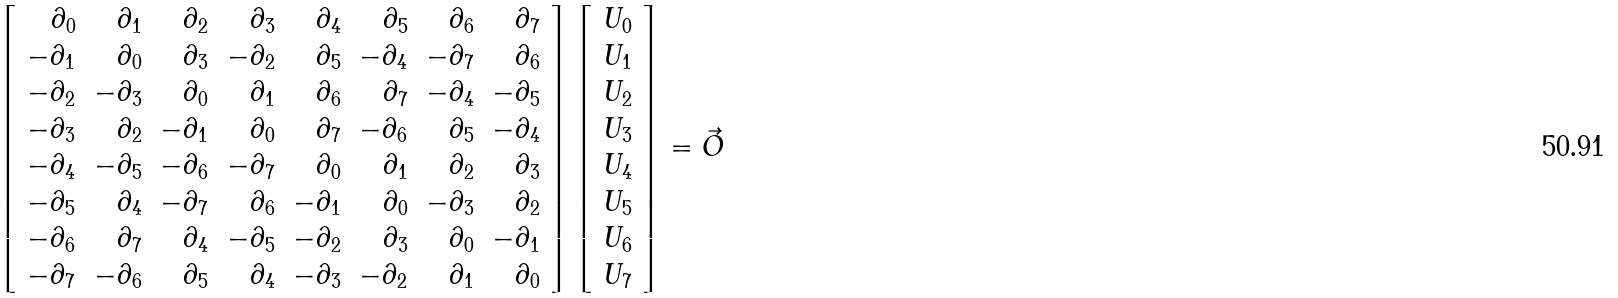Convert formula to latex. <formula><loc_0><loc_0><loc_500><loc_500>\left [ \begin{array} { r r r r r r r r } \partial _ { 0 } & \partial _ { 1 } & \partial _ { 2 } & \partial _ { 3 } & \partial _ { 4 } & \partial _ { 5 } & \partial _ { 6 } & \partial _ { 7 } \\ - \partial _ { 1 } & \partial _ { 0 } & \partial _ { 3 } & - \partial _ { 2 } & \partial _ { 5 } & - \partial _ { 4 } & - \partial _ { 7 } & \partial _ { 6 } \\ - \partial _ { 2 } & - \partial _ { 3 } & \partial _ { 0 } & \partial _ { 1 } & \partial _ { 6 } & \partial _ { 7 } & - \partial _ { 4 } & - \partial _ { 5 } \\ - \partial _ { 3 } & \partial _ { 2 } & - \partial _ { 1 } & \partial _ { 0 } & \partial _ { 7 } & - \partial _ { 6 } & \partial _ { 5 } & - \partial _ { 4 } \\ - \partial _ { 4 } & - \partial _ { 5 } & - \partial _ { 6 } & - \partial _ { 7 } & \partial _ { 0 } & \partial _ { 1 } & \partial _ { 2 } & \partial _ { 3 } \\ - \partial _ { 5 } & \partial _ { 4 } & - \partial _ { 7 } & \partial _ { 6 } & - \partial _ { 1 } & \partial _ { 0 } & - \partial _ { 3 } & \partial _ { 2 } \\ - \partial _ { 6 } & \partial _ { 7 } & \partial _ { 4 } & - \partial _ { 5 } & - \partial _ { 2 } & \partial _ { 3 } & \partial _ { 0 } & - \partial _ { 1 } \\ - \partial _ { 7 } & - \partial _ { 6 } & \partial _ { 5 } & \partial _ { 4 } & - \partial _ { 3 } & - \partial _ { 2 } & \partial _ { 1 } & \partial _ { 0 } \\ \end{array} \right ] \left [ \begin{array} { l } U _ { 0 } \\ U _ { 1 } \\ U _ { 2 } \\ U _ { 3 } \\ U _ { 4 } \\ U _ { 5 } \\ U _ { 6 } \\ U _ { 7 } \end{array} \right ] = \vec { O }</formula> 